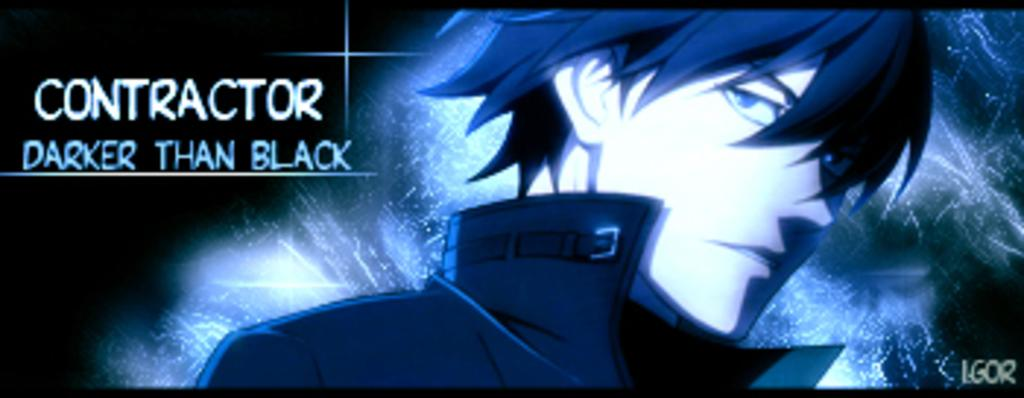What is the main subject of the image? There is a digital art of a man in the image. Can you describe any additional elements in the image? There is some text on the left side of the image. How many spiders are crawling on the throne in the image? There is no throne or spiders present in the image; it features a digital art of a man and some text. 